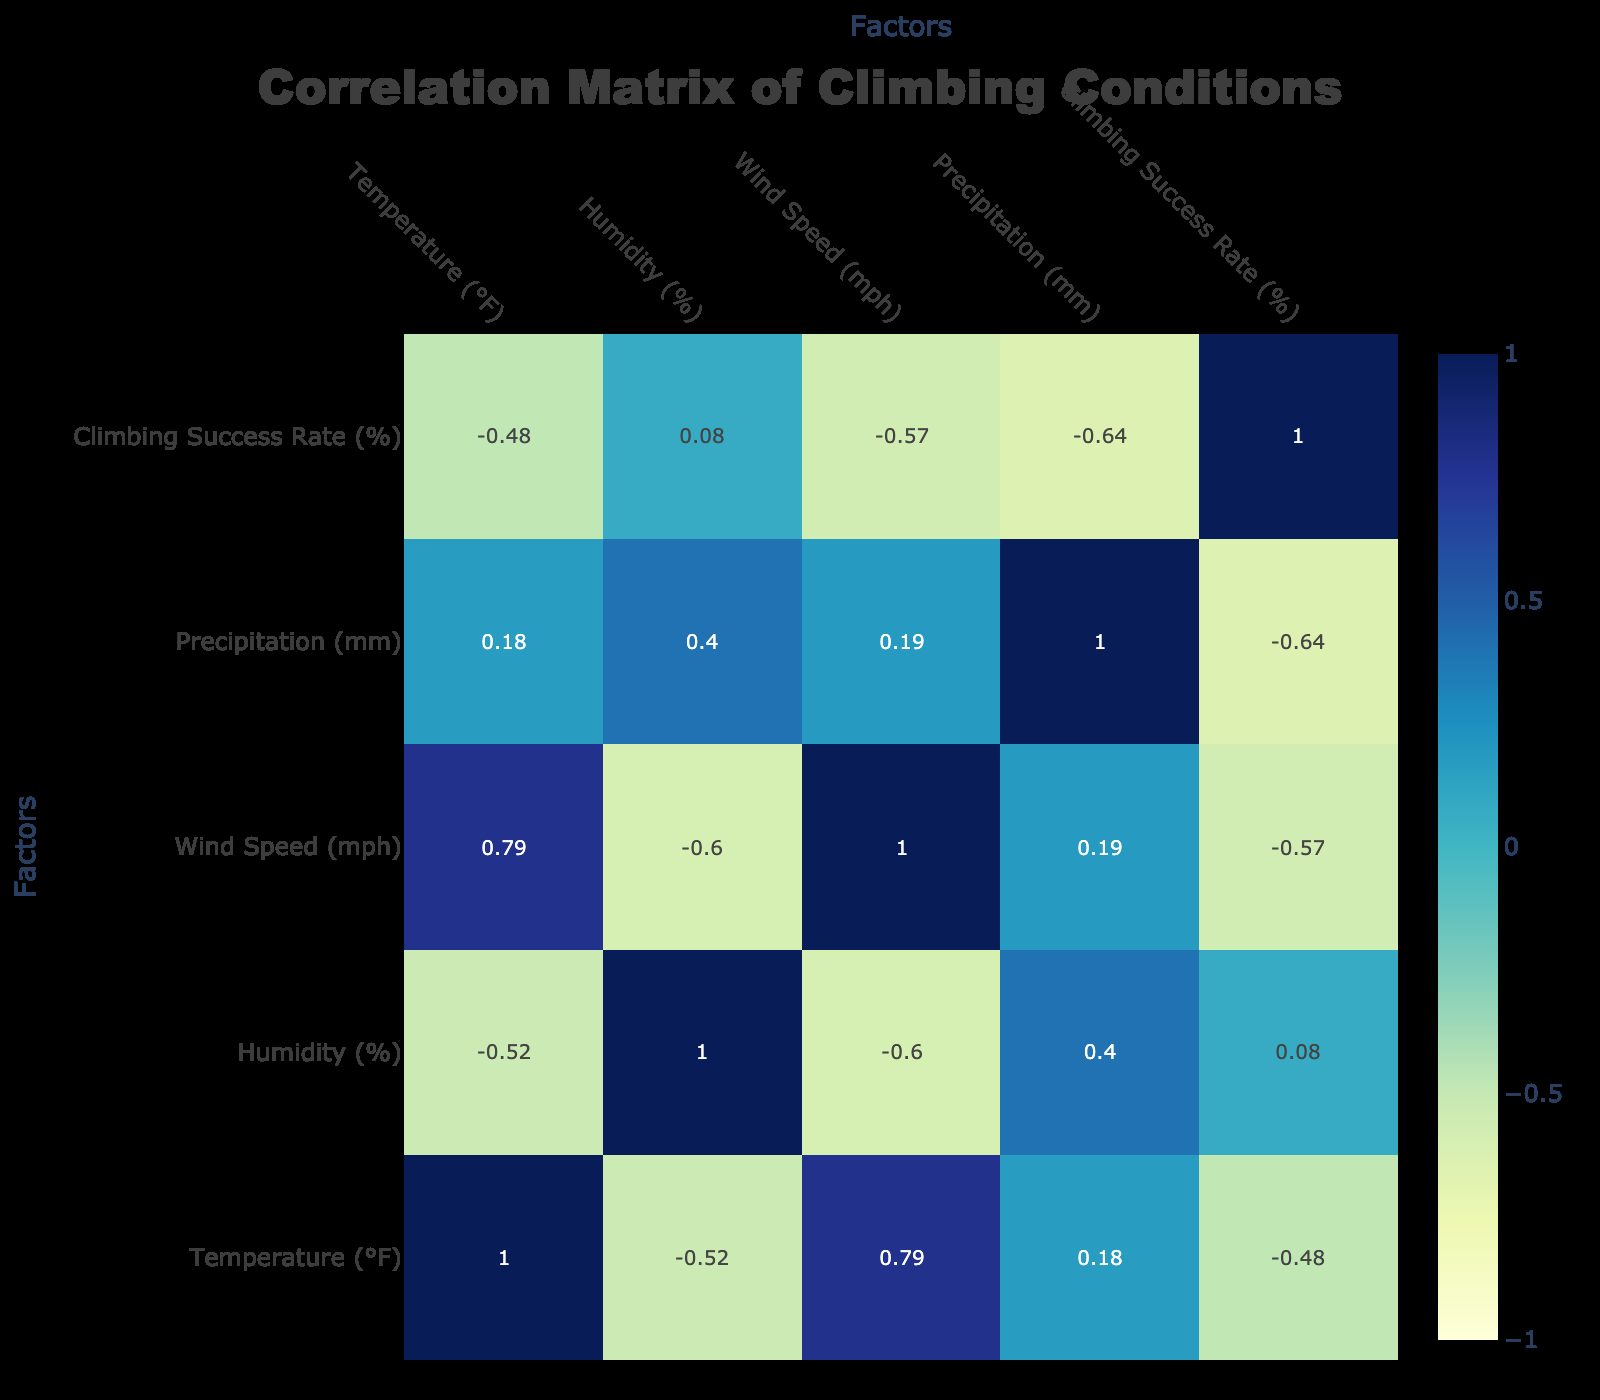What is the climbing success rate in Yosemite Valley? The climbing success rate for Yosemite Valley is explicitly listed in the table as 85%.
Answer: 85% What is the wind speed in Joshua Tree? The wind speed in Joshua Tree is stated in the table as 15 mph.
Answer: 15 mph Which crag has the highest climbing success rate? Looking at the climbing success rates listed, Shawangunk Ridge has the highest rate at 95%.
Answer: 95% What is the average temperature across all crags listed? To find the average temperature, sum all the temperatures: 75 + 70 + 85 + 78 + 90 + 65 + 60 + 70 + 65 + 80 =  78 and divide by the number of crags, which is 10. Therefore, 780/10 = 78°F.
Answer: 78°F Is the climbing success rate positively correlated with lower humidity? By examining the correlation values between humidity and climbing success rate in the table, we see that lower humidity (e.g., 15% or 20%) corresponds with higher success rates. Although a detailed correlation coefficient is not provided, we can infer that there appears to be a positive trend.
Answer: Yes If the humidity is at 30%, what would be the potential climbing success rates seen in the table? From the table, crags with 30% humidity are Yosemite Valley with a success rate of 85% and Boulder Canyon with a success rate of 88%. Therefore, one can expect success rates to be within that range at 30% humidity.
Answer: 85% to 88% What is the difference in climbing success rates between the crags with the highest and the lowest temperature? The highest temperature recorded is Joshua Tree at 90°F, with a climbing success rate of 75%. The lowest temperature is Banff at 60°F, with a climbing success rate of 80%. The difference is 80 - 75 = 5%.
Answer: 5% Does Red River Gorge have a higher climbing success rate than Smith Rock? According to the table, Red River Gorge has a success rate of 70%, while Smith Rock has a higher rate of 80%. Thus, Red River Gorge does not have a higher success rate than Smith Rock.
Answer: No What percentage of crags have a climbing success rate of 80% or above? From the table, the crags with 80% or above success rates are Yosemite Valley (85%), Smith Rock (80%), Jumbo Rocks (90%), Shawangunk Ridge (95%), and Boulder Canyon (88%). There are 5 crags with rates 80% or above out of the 10 total crags, so the percentage is (5/10)*100 = 50%.
Answer: 50% 